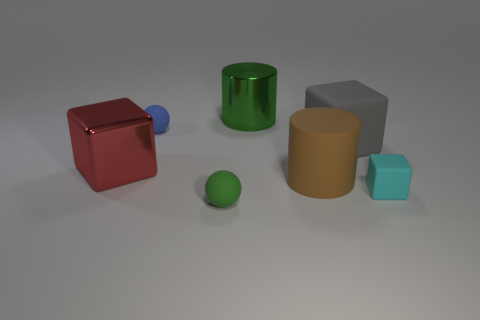Do the cyan matte thing and the green metallic cylinder have the same size?
Offer a terse response. No. Are there any big matte cylinders that are right of the metallic thing left of the tiny ball behind the small green matte thing?
Offer a very short reply. Yes. What shape is the blue matte thing that is the same size as the green matte object?
Offer a very short reply. Sphere. Are there any tiny rubber things of the same color as the shiny cylinder?
Make the answer very short. Yes. Do the big gray thing and the large green object have the same shape?
Offer a very short reply. No. How many large things are green metal objects or cyan rubber things?
Your answer should be very brief. 1. The large thing that is made of the same material as the big brown cylinder is what color?
Offer a very short reply. Gray. What number of other big cylinders are made of the same material as the brown cylinder?
Your answer should be very brief. 0. There is a object that is right of the large gray matte thing; is it the same size as the rubber sphere that is behind the large rubber cylinder?
Offer a very short reply. Yes. What is the material of the large thing on the left side of the metallic thing that is on the right side of the green ball?
Offer a very short reply. Metal. 